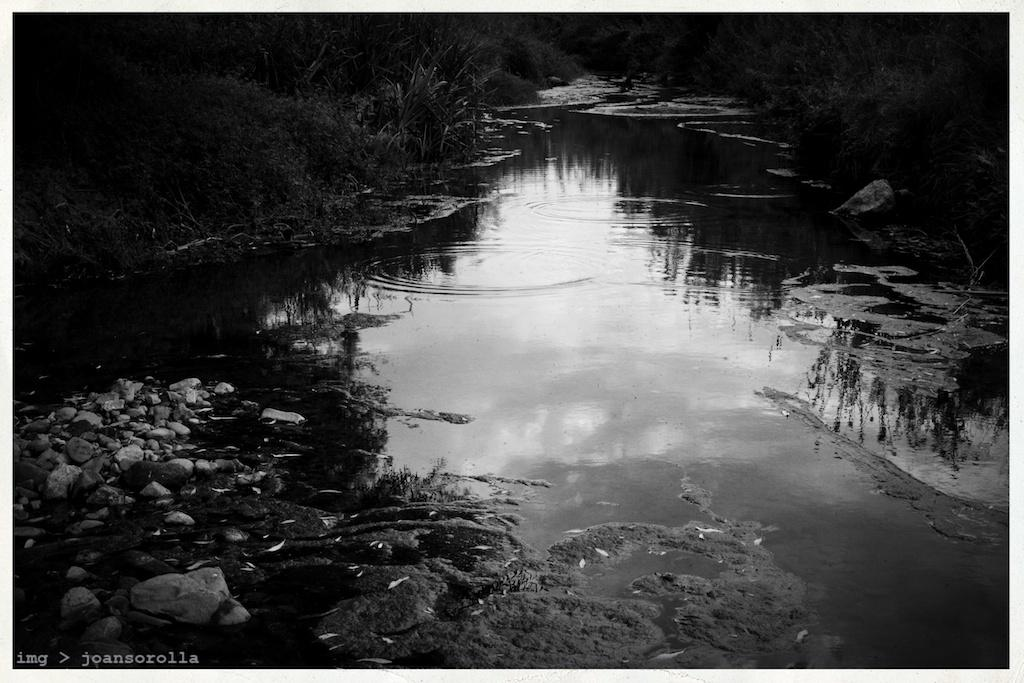What is present on both sides of the image? There are plants on both the right and left sides of the image. What can be seen in the water on the bottom left of the image? There are covers in the water on the bottom left of the image. How many sheep are visible in the image? There are no sheep present in the image. What type of society is depicted in the image? The image does not depict any society; it features plants and covers in the water. 